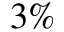<formula> <loc_0><loc_0><loc_500><loc_500>3 \%</formula> 